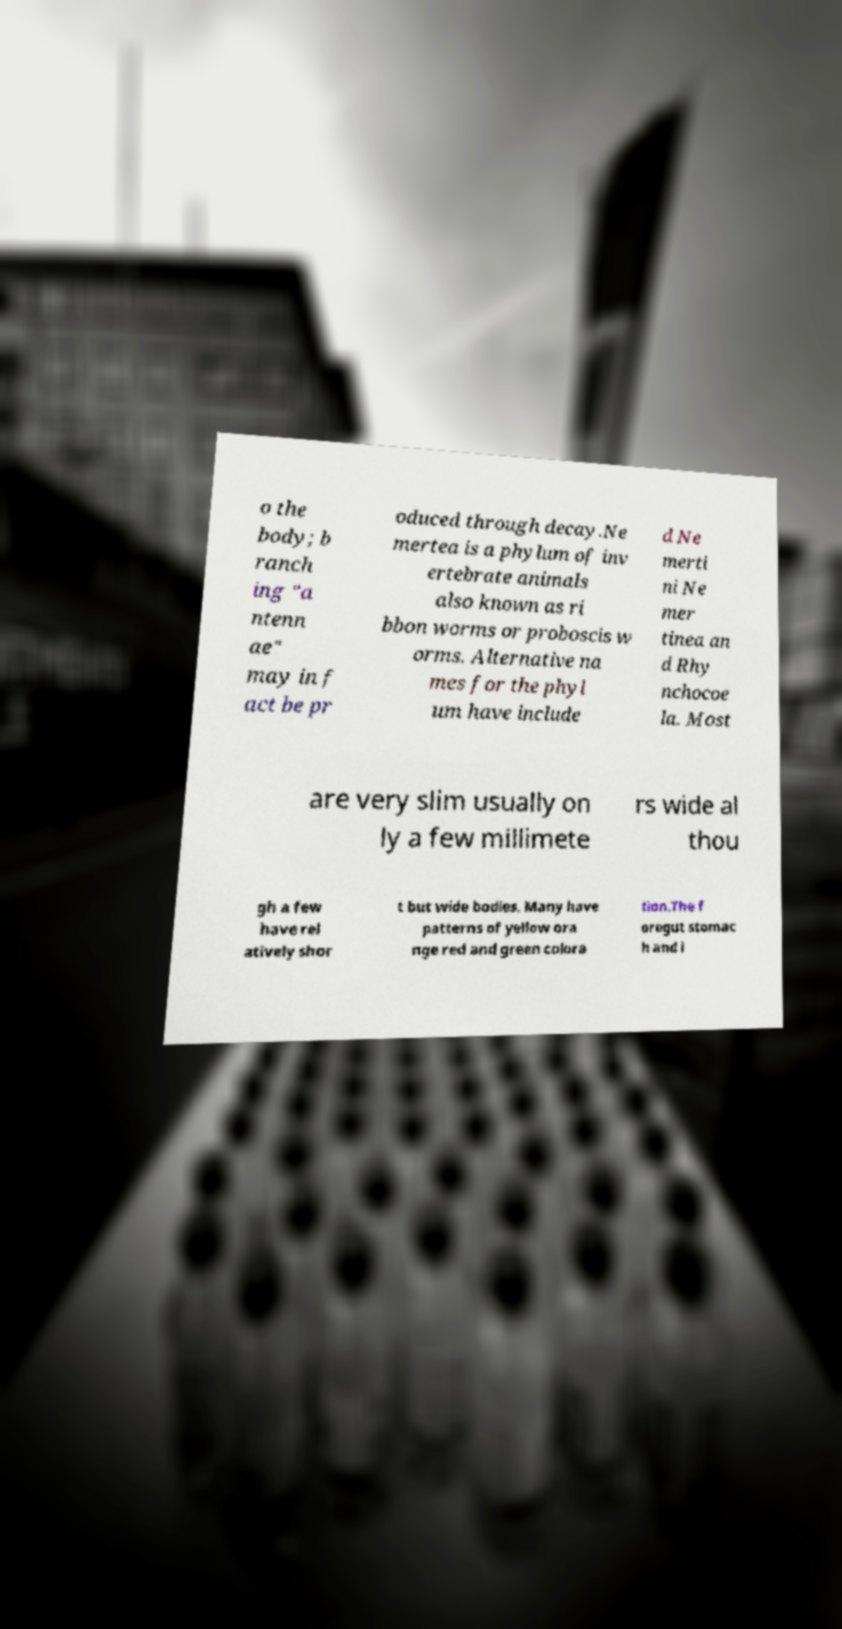Please read and relay the text visible in this image. What does it say? o the body; b ranch ing "a ntenn ae" may in f act be pr oduced through decay.Ne mertea is a phylum of inv ertebrate animals also known as ri bbon worms or proboscis w orms. Alternative na mes for the phyl um have include d Ne merti ni Ne mer tinea an d Rhy nchocoe la. Most are very slim usually on ly a few millimete rs wide al thou gh a few have rel atively shor t but wide bodies. Many have patterns of yellow ora nge red and green colora tion.The f oregut stomac h and i 